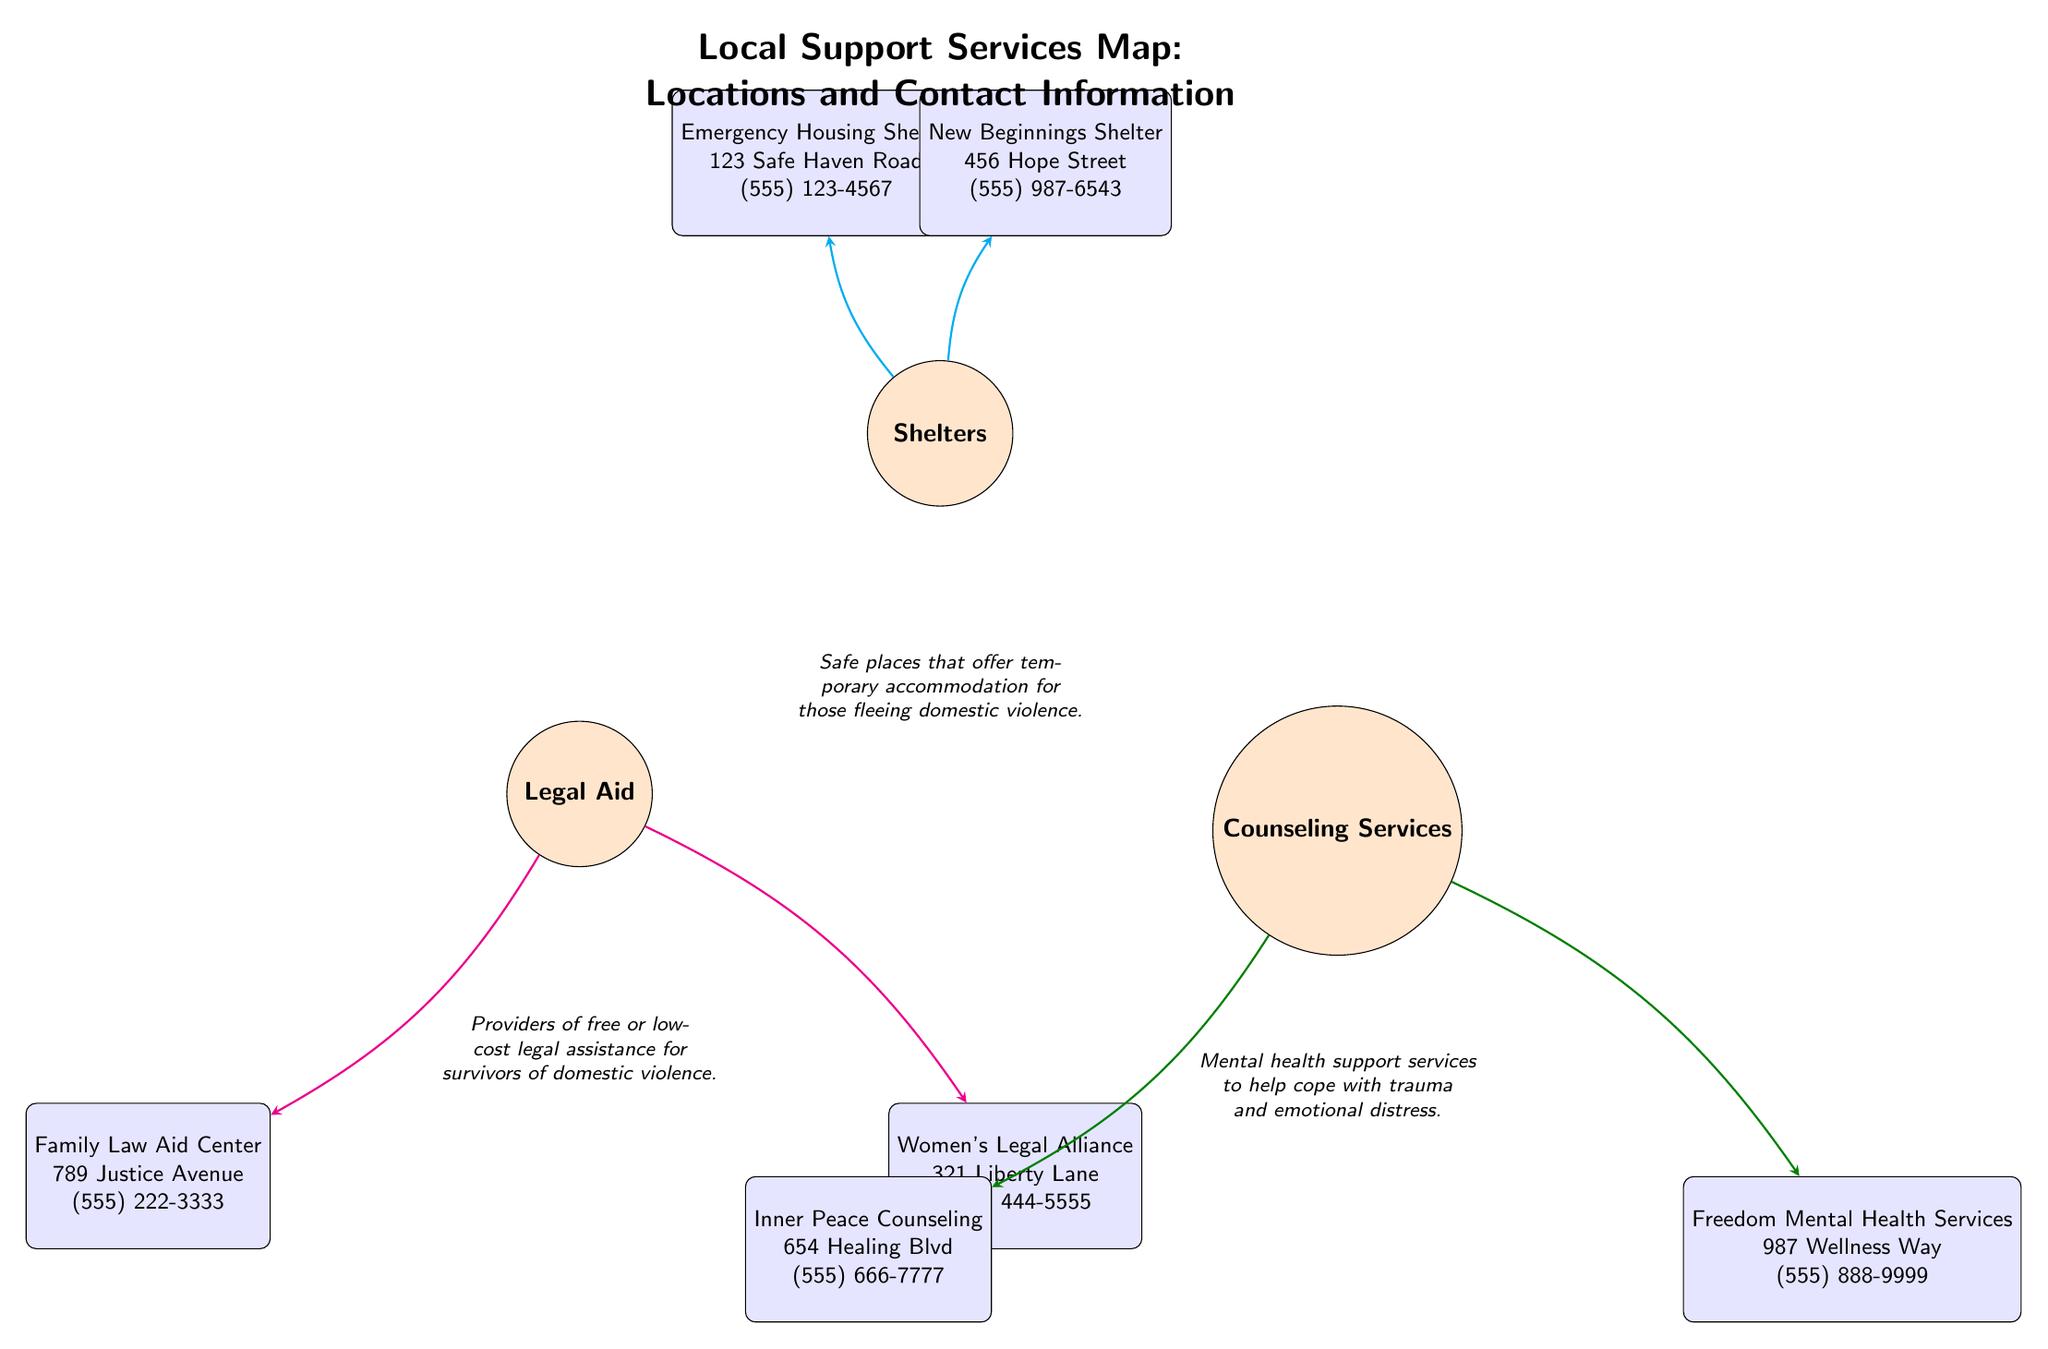What are the names of the two shelters listed? The diagram provides information on two shelters. By locating the "Shelters" node and looking for the connected nodes with service information, the two names can be found: "Emergency Housing Shelter" and "New Beginnings Shelter".
Answer: Emergency Housing Shelter, New Beginnings Shelter How many legal aid services are listed? Counting the nodes connected to the "Legal Aid" main node in the diagram provides the answer. There are two service nodes connected, which are "Family Law Aid Center" and "Women's Legal Alliance".
Answer: 2 What is the contact number for the Inner Peace Counseling service? By finding the “Counseling Services” node and tracing the arrow to the "Inner Peace Counseling" service node, the contact number can be read directly from it, which is (555) 666-7777.
Answer: (555) 666-7777 Which node directly connects to the "Shelters" main node? Looking at the arrows emanating from the "Shelters" main node, the service nodes are linked directly to it. Thus, both "Emergency Housing Shelter" and "New Beginnings Shelter" are directly connected.
Answer: Emergency Housing Shelter, New Beginnings Shelter What type of support do counseling services provide? Referring to the description under the "Counseling Services" main node, it states that these services provide "Mental health support services to help cope with trauma and emotional distress." This gives insight into the type of support offered.
Answer: Mental health support services How many service nodes are related to the "Counseling Services" main node? By checking the connections from the "Counseling Services" main node, two service nodes are identified: "Inner Peace Counseling" and "Freedom Mental Health Services". Thus, there are two service nodes related to counseling services.
Answer: 2 What is the address of the Women's Legal Alliance? To find the address, locate the "Women's Legal Alliance" service node and read the information connected with it. The address provided is "321 Liberty Lane".
Answer: 321 Liberty Lane Which service node provides emergency housing? By locating the "Shelters" main node and investigating its connected service nodes, "Emergency Housing Shelter" is identified as the service offering emergency housing.
Answer: Emergency Housing Shelter What do the arrows in the diagram represent? The arrows in the diagram represent the flow of information or connection between the main service categories and their related service nodes. They show the relationship of support services to their respective areas.
Answer: Connection to services 